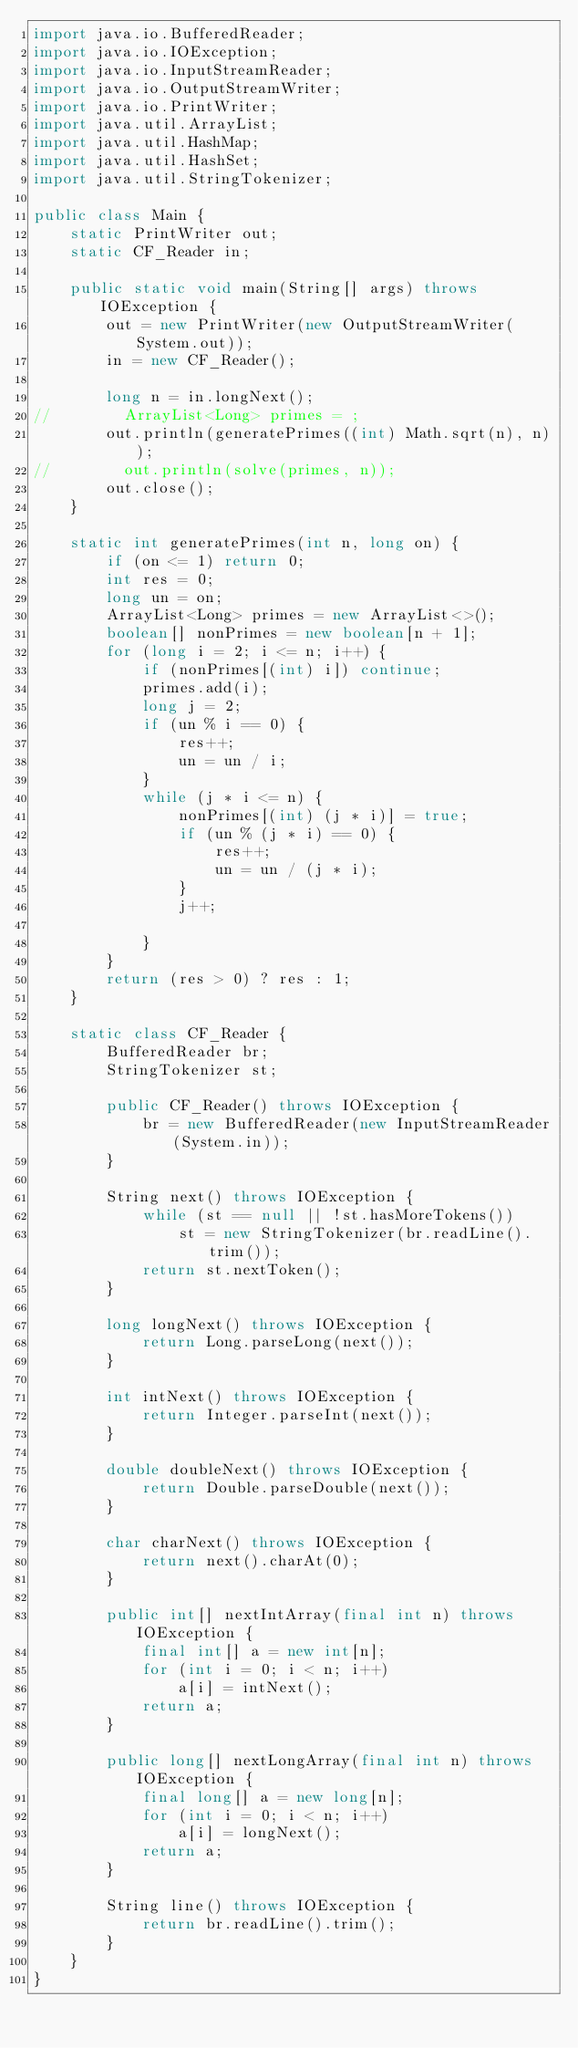<code> <loc_0><loc_0><loc_500><loc_500><_Java_>import java.io.BufferedReader;
import java.io.IOException;
import java.io.InputStreamReader;
import java.io.OutputStreamWriter;
import java.io.PrintWriter;
import java.util.ArrayList;
import java.util.HashMap;
import java.util.HashSet;
import java.util.StringTokenizer;

public class Main {
    static PrintWriter out;
    static CF_Reader in;

    public static void main(String[] args) throws IOException {
        out = new PrintWriter(new OutputStreamWriter(System.out));
        in = new CF_Reader();

        long n = in.longNext();
//        ArrayList<Long> primes = ;
        out.println(generatePrimes((int) Math.sqrt(n), n));
//        out.println(solve(primes, n));
        out.close();
    }

    static int generatePrimes(int n, long on) {
        if (on <= 1) return 0;
        int res = 0;
        long un = on;
        ArrayList<Long> primes = new ArrayList<>();
        boolean[] nonPrimes = new boolean[n + 1];
        for (long i = 2; i <= n; i++) {
            if (nonPrimes[(int) i]) continue;
            primes.add(i);
            long j = 2;
            if (un % i == 0) {
                res++;
                un = un / i;
            }
            while (j * i <= n) {
                nonPrimes[(int) (j * i)] = true;
                if (un % (j * i) == 0) {
                    res++;
                    un = un / (j * i);
                }
                j++;

            }
        }
        return (res > 0) ? res : 1;
    }

    static class CF_Reader {
        BufferedReader br;
        StringTokenizer st;

        public CF_Reader() throws IOException {
            br = new BufferedReader(new InputStreamReader(System.in));
        }

        String next() throws IOException {
            while (st == null || !st.hasMoreTokens())
                st = new StringTokenizer(br.readLine().trim());
            return st.nextToken();
        }

        long longNext() throws IOException {
            return Long.parseLong(next());
        }

        int intNext() throws IOException {
            return Integer.parseInt(next());
        }

        double doubleNext() throws IOException {
            return Double.parseDouble(next());
        }

        char charNext() throws IOException {
            return next().charAt(0);
        }

        public int[] nextIntArray(final int n) throws IOException {
            final int[] a = new int[n];
            for (int i = 0; i < n; i++)
                a[i] = intNext();
            return a;
        }

        public long[] nextLongArray(final int n) throws IOException {
            final long[] a = new long[n];
            for (int i = 0; i < n; i++)
                a[i] = longNext();
            return a;
        }

        String line() throws IOException {
            return br.readLine().trim();
        }
    }
}


</code> 